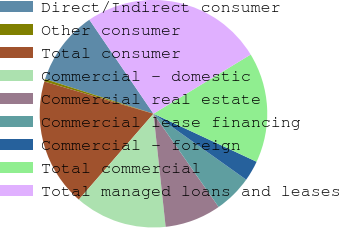Convert chart to OTSL. <chart><loc_0><loc_0><loc_500><loc_500><pie_chart><fcel>Direct/Indirect consumer<fcel>Other consumer<fcel>Total consumer<fcel>Commercial - domestic<fcel>Commercial real estate<fcel>Commercial lease financing<fcel>Commercial - foreign<fcel>Total commercial<fcel>Total managed loans and leases<nl><fcel>10.55%<fcel>0.36%<fcel>18.18%<fcel>13.09%<fcel>8.0%<fcel>5.45%<fcel>2.91%<fcel>15.64%<fcel>25.82%<nl></chart> 